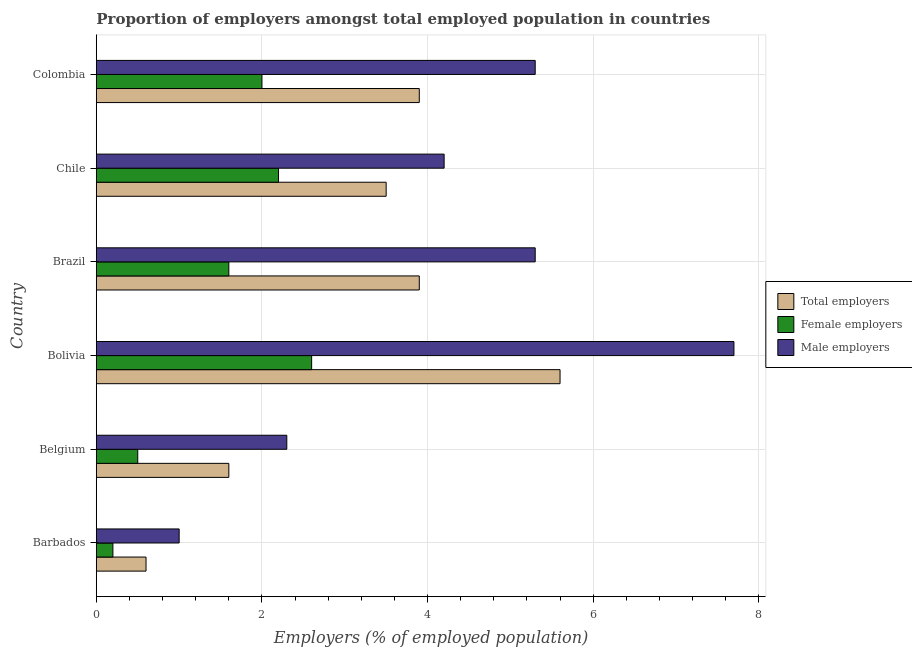How many groups of bars are there?
Make the answer very short. 6. Are the number of bars per tick equal to the number of legend labels?
Provide a succinct answer. Yes. Are the number of bars on each tick of the Y-axis equal?
Give a very brief answer. Yes. How many bars are there on the 3rd tick from the top?
Keep it short and to the point. 3. Across all countries, what is the maximum percentage of total employers?
Give a very brief answer. 5.6. Across all countries, what is the minimum percentage of female employers?
Offer a terse response. 0.2. In which country was the percentage of male employers maximum?
Provide a short and direct response. Bolivia. In which country was the percentage of female employers minimum?
Provide a succinct answer. Barbados. What is the total percentage of female employers in the graph?
Make the answer very short. 9.1. What is the difference between the percentage of female employers in Bolivia and the percentage of total employers in Barbados?
Offer a terse response. 2. What is the average percentage of female employers per country?
Your answer should be compact. 1.52. What is the difference between the percentage of male employers and percentage of total employers in Bolivia?
Make the answer very short. 2.1. What is the ratio of the percentage of male employers in Belgium to that in Chile?
Your answer should be very brief. 0.55. Is the percentage of total employers in Bolivia less than that in Chile?
Offer a terse response. No. Is the difference between the percentage of female employers in Belgium and Bolivia greater than the difference between the percentage of total employers in Belgium and Bolivia?
Your answer should be very brief. Yes. What is the difference between the highest and the second highest percentage of total employers?
Your response must be concise. 1.7. In how many countries, is the percentage of total employers greater than the average percentage of total employers taken over all countries?
Provide a short and direct response. 4. What does the 2nd bar from the top in Colombia represents?
Your answer should be compact. Female employers. What does the 1st bar from the bottom in Bolivia represents?
Offer a very short reply. Total employers. Is it the case that in every country, the sum of the percentage of total employers and percentage of female employers is greater than the percentage of male employers?
Your answer should be compact. No. How many bars are there?
Offer a terse response. 18. Are all the bars in the graph horizontal?
Your answer should be compact. Yes. What is the difference between two consecutive major ticks on the X-axis?
Make the answer very short. 2. Are the values on the major ticks of X-axis written in scientific E-notation?
Your answer should be compact. No. Does the graph contain grids?
Your response must be concise. Yes. How many legend labels are there?
Provide a succinct answer. 3. What is the title of the graph?
Keep it short and to the point. Proportion of employers amongst total employed population in countries. Does "Infant(male)" appear as one of the legend labels in the graph?
Your answer should be very brief. No. What is the label or title of the X-axis?
Offer a terse response. Employers (% of employed population). What is the Employers (% of employed population) of Total employers in Barbados?
Provide a succinct answer. 0.6. What is the Employers (% of employed population) of Female employers in Barbados?
Offer a very short reply. 0.2. What is the Employers (% of employed population) in Total employers in Belgium?
Make the answer very short. 1.6. What is the Employers (% of employed population) in Female employers in Belgium?
Offer a terse response. 0.5. What is the Employers (% of employed population) of Male employers in Belgium?
Provide a short and direct response. 2.3. What is the Employers (% of employed population) in Total employers in Bolivia?
Provide a succinct answer. 5.6. What is the Employers (% of employed population) of Female employers in Bolivia?
Your answer should be very brief. 2.6. What is the Employers (% of employed population) of Male employers in Bolivia?
Your answer should be very brief. 7.7. What is the Employers (% of employed population) in Total employers in Brazil?
Your answer should be compact. 3.9. What is the Employers (% of employed population) in Female employers in Brazil?
Your answer should be very brief. 1.6. What is the Employers (% of employed population) in Male employers in Brazil?
Provide a short and direct response. 5.3. What is the Employers (% of employed population) of Total employers in Chile?
Ensure brevity in your answer.  3.5. What is the Employers (% of employed population) of Female employers in Chile?
Your answer should be compact. 2.2. What is the Employers (% of employed population) in Male employers in Chile?
Make the answer very short. 4.2. What is the Employers (% of employed population) of Total employers in Colombia?
Offer a very short reply. 3.9. What is the Employers (% of employed population) of Female employers in Colombia?
Provide a short and direct response. 2. What is the Employers (% of employed population) in Male employers in Colombia?
Give a very brief answer. 5.3. Across all countries, what is the maximum Employers (% of employed population) in Total employers?
Provide a succinct answer. 5.6. Across all countries, what is the maximum Employers (% of employed population) of Female employers?
Give a very brief answer. 2.6. Across all countries, what is the maximum Employers (% of employed population) of Male employers?
Give a very brief answer. 7.7. Across all countries, what is the minimum Employers (% of employed population) in Total employers?
Your answer should be compact. 0.6. Across all countries, what is the minimum Employers (% of employed population) in Female employers?
Offer a very short reply. 0.2. Across all countries, what is the minimum Employers (% of employed population) in Male employers?
Offer a terse response. 1. What is the total Employers (% of employed population) of Female employers in the graph?
Keep it short and to the point. 9.1. What is the total Employers (% of employed population) in Male employers in the graph?
Provide a succinct answer. 25.8. What is the difference between the Employers (% of employed population) in Total employers in Barbados and that in Belgium?
Your answer should be compact. -1. What is the difference between the Employers (% of employed population) in Female employers in Barbados and that in Belgium?
Keep it short and to the point. -0.3. What is the difference between the Employers (% of employed population) of Male employers in Barbados and that in Belgium?
Offer a terse response. -1.3. What is the difference between the Employers (% of employed population) in Female employers in Barbados and that in Bolivia?
Ensure brevity in your answer.  -2.4. What is the difference between the Employers (% of employed population) in Male employers in Barbados and that in Bolivia?
Offer a very short reply. -6.7. What is the difference between the Employers (% of employed population) of Total employers in Barbados and that in Brazil?
Your answer should be very brief. -3.3. What is the difference between the Employers (% of employed population) in Female employers in Barbados and that in Brazil?
Your response must be concise. -1.4. What is the difference between the Employers (% of employed population) in Total employers in Barbados and that in Chile?
Give a very brief answer. -2.9. What is the difference between the Employers (% of employed population) in Female employers in Barbados and that in Chile?
Ensure brevity in your answer.  -2. What is the difference between the Employers (% of employed population) of Total employers in Barbados and that in Colombia?
Offer a terse response. -3.3. What is the difference between the Employers (% of employed population) in Female employers in Barbados and that in Colombia?
Provide a succinct answer. -1.8. What is the difference between the Employers (% of employed population) of Male employers in Barbados and that in Colombia?
Your answer should be compact. -4.3. What is the difference between the Employers (% of employed population) in Total employers in Belgium and that in Bolivia?
Keep it short and to the point. -4. What is the difference between the Employers (% of employed population) in Male employers in Belgium and that in Bolivia?
Provide a short and direct response. -5.4. What is the difference between the Employers (% of employed population) in Female employers in Belgium and that in Brazil?
Your answer should be very brief. -1.1. What is the difference between the Employers (% of employed population) of Male employers in Belgium and that in Brazil?
Your response must be concise. -3. What is the difference between the Employers (% of employed population) in Total employers in Bolivia and that in Brazil?
Offer a very short reply. 1.7. What is the difference between the Employers (% of employed population) in Male employers in Bolivia and that in Brazil?
Provide a succinct answer. 2.4. What is the difference between the Employers (% of employed population) of Total employers in Bolivia and that in Chile?
Provide a succinct answer. 2.1. What is the difference between the Employers (% of employed population) in Female employers in Bolivia and that in Chile?
Make the answer very short. 0.4. What is the difference between the Employers (% of employed population) of Male employers in Bolivia and that in Chile?
Make the answer very short. 3.5. What is the difference between the Employers (% of employed population) of Total employers in Bolivia and that in Colombia?
Offer a terse response. 1.7. What is the difference between the Employers (% of employed population) in Total employers in Brazil and that in Chile?
Provide a succinct answer. 0.4. What is the difference between the Employers (% of employed population) of Total employers in Brazil and that in Colombia?
Ensure brevity in your answer.  0. What is the difference between the Employers (% of employed population) in Female employers in Brazil and that in Colombia?
Offer a very short reply. -0.4. What is the difference between the Employers (% of employed population) in Female employers in Chile and that in Colombia?
Your answer should be compact. 0.2. What is the difference between the Employers (% of employed population) in Total employers in Barbados and the Employers (% of employed population) in Female employers in Belgium?
Provide a succinct answer. 0.1. What is the difference between the Employers (% of employed population) in Total employers in Barbados and the Employers (% of employed population) in Male employers in Belgium?
Ensure brevity in your answer.  -1.7. What is the difference between the Employers (% of employed population) in Female employers in Barbados and the Employers (% of employed population) in Male employers in Belgium?
Keep it short and to the point. -2.1. What is the difference between the Employers (% of employed population) in Total employers in Barbados and the Employers (% of employed population) in Male employers in Bolivia?
Offer a very short reply. -7.1. What is the difference between the Employers (% of employed population) of Total employers in Barbados and the Employers (% of employed population) of Female employers in Brazil?
Offer a very short reply. -1. What is the difference between the Employers (% of employed population) in Total employers in Barbados and the Employers (% of employed population) in Female employers in Chile?
Make the answer very short. -1.6. What is the difference between the Employers (% of employed population) in Total employers in Barbados and the Employers (% of employed population) in Male employers in Chile?
Your answer should be compact. -3.6. What is the difference between the Employers (% of employed population) in Total employers in Barbados and the Employers (% of employed population) in Male employers in Colombia?
Provide a succinct answer. -4.7. What is the difference between the Employers (% of employed population) of Total employers in Belgium and the Employers (% of employed population) of Female employers in Bolivia?
Your response must be concise. -1. What is the difference between the Employers (% of employed population) in Total employers in Belgium and the Employers (% of employed population) in Male employers in Bolivia?
Your response must be concise. -6.1. What is the difference between the Employers (% of employed population) in Female employers in Belgium and the Employers (% of employed population) in Male employers in Bolivia?
Provide a succinct answer. -7.2. What is the difference between the Employers (% of employed population) of Total employers in Belgium and the Employers (% of employed population) of Female employers in Brazil?
Provide a succinct answer. 0. What is the difference between the Employers (% of employed population) in Total employers in Belgium and the Employers (% of employed population) in Male employers in Brazil?
Provide a short and direct response. -3.7. What is the difference between the Employers (% of employed population) of Female employers in Belgium and the Employers (% of employed population) of Male employers in Brazil?
Provide a succinct answer. -4.8. What is the difference between the Employers (% of employed population) of Female employers in Belgium and the Employers (% of employed population) of Male employers in Chile?
Offer a very short reply. -3.7. What is the difference between the Employers (% of employed population) in Total employers in Bolivia and the Employers (% of employed population) in Male employers in Brazil?
Offer a terse response. 0.3. What is the difference between the Employers (% of employed population) in Female employers in Bolivia and the Employers (% of employed population) in Male employers in Brazil?
Your answer should be compact. -2.7. What is the difference between the Employers (% of employed population) in Total employers in Bolivia and the Employers (% of employed population) in Female employers in Chile?
Keep it short and to the point. 3.4. What is the difference between the Employers (% of employed population) in Total employers in Bolivia and the Employers (% of employed population) in Female employers in Colombia?
Ensure brevity in your answer.  3.6. What is the difference between the Employers (% of employed population) in Total employers in Bolivia and the Employers (% of employed population) in Male employers in Colombia?
Make the answer very short. 0.3. What is the difference between the Employers (% of employed population) in Female employers in Bolivia and the Employers (% of employed population) in Male employers in Colombia?
Your answer should be compact. -2.7. What is the difference between the Employers (% of employed population) of Total employers in Brazil and the Employers (% of employed population) of Female employers in Chile?
Your answer should be very brief. 1.7. What is the difference between the Employers (% of employed population) in Total employers in Brazil and the Employers (% of employed population) in Male employers in Colombia?
Ensure brevity in your answer.  -1.4. What is the difference between the Employers (% of employed population) in Female employers in Brazil and the Employers (% of employed population) in Male employers in Colombia?
Your response must be concise. -3.7. What is the difference between the Employers (% of employed population) of Total employers in Chile and the Employers (% of employed population) of Female employers in Colombia?
Your answer should be compact. 1.5. What is the difference between the Employers (% of employed population) of Total employers in Chile and the Employers (% of employed population) of Male employers in Colombia?
Your response must be concise. -1.8. What is the average Employers (% of employed population) in Total employers per country?
Keep it short and to the point. 3.18. What is the average Employers (% of employed population) in Female employers per country?
Your answer should be very brief. 1.52. What is the average Employers (% of employed population) of Male employers per country?
Provide a short and direct response. 4.3. What is the difference between the Employers (% of employed population) of Total employers and Employers (% of employed population) of Male employers in Barbados?
Provide a short and direct response. -0.4. What is the difference between the Employers (% of employed population) in Total employers and Employers (% of employed population) in Male employers in Belgium?
Offer a terse response. -0.7. What is the difference between the Employers (% of employed population) of Total employers and Employers (% of employed population) of Male employers in Bolivia?
Make the answer very short. -2.1. What is the difference between the Employers (% of employed population) of Female employers and Employers (% of employed population) of Male employers in Bolivia?
Your answer should be compact. -5.1. What is the difference between the Employers (% of employed population) of Female employers and Employers (% of employed population) of Male employers in Brazil?
Give a very brief answer. -3.7. What is the difference between the Employers (% of employed population) of Total employers and Employers (% of employed population) of Male employers in Chile?
Make the answer very short. -0.7. What is the difference between the Employers (% of employed population) in Female employers and Employers (% of employed population) in Male employers in Chile?
Make the answer very short. -2. What is the ratio of the Employers (% of employed population) of Female employers in Barbados to that in Belgium?
Offer a terse response. 0.4. What is the ratio of the Employers (% of employed population) in Male employers in Barbados to that in Belgium?
Offer a very short reply. 0.43. What is the ratio of the Employers (% of employed population) of Total employers in Barbados to that in Bolivia?
Your response must be concise. 0.11. What is the ratio of the Employers (% of employed population) of Female employers in Barbados to that in Bolivia?
Your response must be concise. 0.08. What is the ratio of the Employers (% of employed population) of Male employers in Barbados to that in Bolivia?
Offer a terse response. 0.13. What is the ratio of the Employers (% of employed population) in Total employers in Barbados to that in Brazil?
Offer a terse response. 0.15. What is the ratio of the Employers (% of employed population) of Male employers in Barbados to that in Brazil?
Provide a succinct answer. 0.19. What is the ratio of the Employers (% of employed population) in Total employers in Barbados to that in Chile?
Your answer should be compact. 0.17. What is the ratio of the Employers (% of employed population) of Female employers in Barbados to that in Chile?
Provide a short and direct response. 0.09. What is the ratio of the Employers (% of employed population) in Male employers in Barbados to that in Chile?
Provide a succinct answer. 0.24. What is the ratio of the Employers (% of employed population) of Total employers in Barbados to that in Colombia?
Offer a very short reply. 0.15. What is the ratio of the Employers (% of employed population) of Male employers in Barbados to that in Colombia?
Keep it short and to the point. 0.19. What is the ratio of the Employers (% of employed population) in Total employers in Belgium to that in Bolivia?
Give a very brief answer. 0.29. What is the ratio of the Employers (% of employed population) in Female employers in Belgium to that in Bolivia?
Your answer should be compact. 0.19. What is the ratio of the Employers (% of employed population) in Male employers in Belgium to that in Bolivia?
Your answer should be compact. 0.3. What is the ratio of the Employers (% of employed population) of Total employers in Belgium to that in Brazil?
Offer a terse response. 0.41. What is the ratio of the Employers (% of employed population) of Female employers in Belgium to that in Brazil?
Offer a very short reply. 0.31. What is the ratio of the Employers (% of employed population) in Male employers in Belgium to that in Brazil?
Provide a succinct answer. 0.43. What is the ratio of the Employers (% of employed population) in Total employers in Belgium to that in Chile?
Ensure brevity in your answer.  0.46. What is the ratio of the Employers (% of employed population) in Female employers in Belgium to that in Chile?
Your answer should be compact. 0.23. What is the ratio of the Employers (% of employed population) of Male employers in Belgium to that in Chile?
Your response must be concise. 0.55. What is the ratio of the Employers (% of employed population) in Total employers in Belgium to that in Colombia?
Keep it short and to the point. 0.41. What is the ratio of the Employers (% of employed population) in Male employers in Belgium to that in Colombia?
Your answer should be very brief. 0.43. What is the ratio of the Employers (% of employed population) in Total employers in Bolivia to that in Brazil?
Ensure brevity in your answer.  1.44. What is the ratio of the Employers (% of employed population) in Female employers in Bolivia to that in Brazil?
Offer a very short reply. 1.62. What is the ratio of the Employers (% of employed population) of Male employers in Bolivia to that in Brazil?
Offer a very short reply. 1.45. What is the ratio of the Employers (% of employed population) of Female employers in Bolivia to that in Chile?
Offer a terse response. 1.18. What is the ratio of the Employers (% of employed population) in Male employers in Bolivia to that in Chile?
Your answer should be compact. 1.83. What is the ratio of the Employers (% of employed population) of Total employers in Bolivia to that in Colombia?
Ensure brevity in your answer.  1.44. What is the ratio of the Employers (% of employed population) of Male employers in Bolivia to that in Colombia?
Ensure brevity in your answer.  1.45. What is the ratio of the Employers (% of employed population) in Total employers in Brazil to that in Chile?
Provide a succinct answer. 1.11. What is the ratio of the Employers (% of employed population) of Female employers in Brazil to that in Chile?
Provide a short and direct response. 0.73. What is the ratio of the Employers (% of employed population) in Male employers in Brazil to that in Chile?
Keep it short and to the point. 1.26. What is the ratio of the Employers (% of employed population) of Total employers in Brazil to that in Colombia?
Your answer should be very brief. 1. What is the ratio of the Employers (% of employed population) in Female employers in Brazil to that in Colombia?
Ensure brevity in your answer.  0.8. What is the ratio of the Employers (% of employed population) of Male employers in Brazil to that in Colombia?
Offer a very short reply. 1. What is the ratio of the Employers (% of employed population) in Total employers in Chile to that in Colombia?
Ensure brevity in your answer.  0.9. What is the ratio of the Employers (% of employed population) of Female employers in Chile to that in Colombia?
Provide a succinct answer. 1.1. What is the ratio of the Employers (% of employed population) in Male employers in Chile to that in Colombia?
Give a very brief answer. 0.79. What is the difference between the highest and the second highest Employers (% of employed population) of Female employers?
Offer a very short reply. 0.4. What is the difference between the highest and the second highest Employers (% of employed population) in Male employers?
Your response must be concise. 2.4. What is the difference between the highest and the lowest Employers (% of employed population) in Total employers?
Provide a short and direct response. 5. What is the difference between the highest and the lowest Employers (% of employed population) in Female employers?
Your response must be concise. 2.4. What is the difference between the highest and the lowest Employers (% of employed population) in Male employers?
Your answer should be compact. 6.7. 